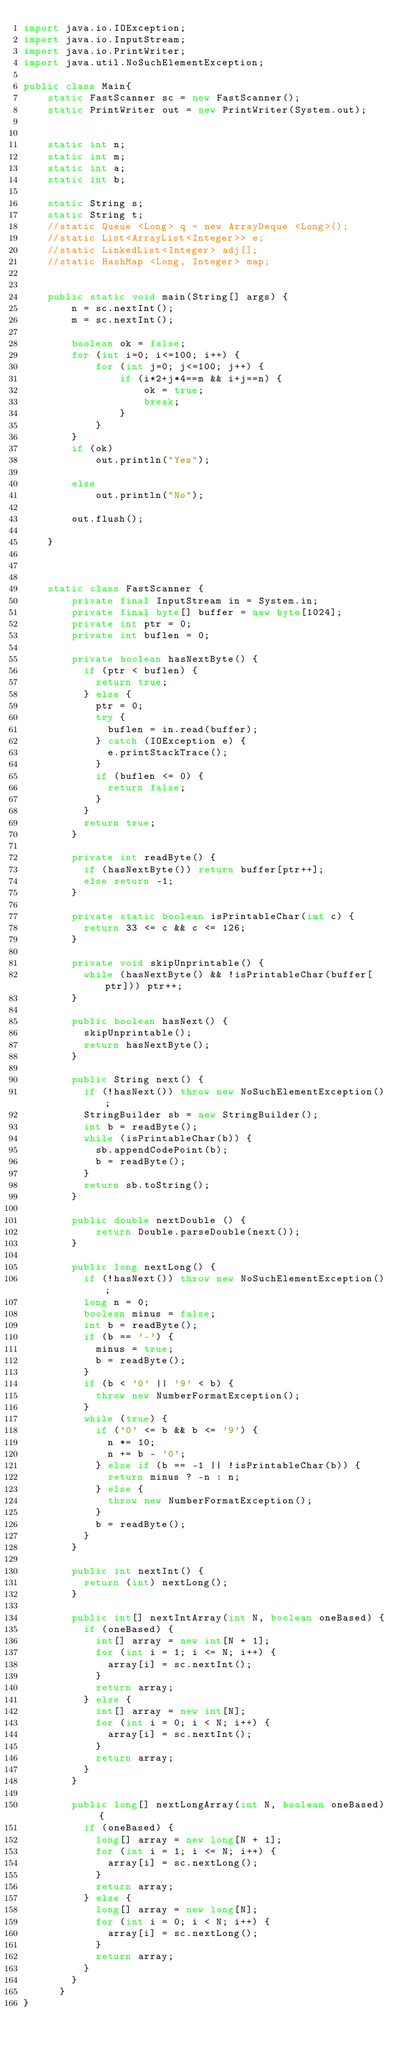Convert code to text. <code><loc_0><loc_0><loc_500><loc_500><_Java_>import java.io.IOException;
import java.io.InputStream;
import java.io.PrintWriter;
import java.util.NoSuchElementException;

public class Main{
	static FastScanner sc = new FastScanner();
	static PrintWriter out = new PrintWriter(System.out);

	
	static int n;
	static int m;
	static int a;
	static int b;
	
	static String s;
	static String t;
	//static Queue <Long> q = new ArrayDeque <Long>();
	//static List<ArrayList<Integer>> e;
	//static LinkedList<Integer> adj[]; 
	//static HashMap <Long, Integer> map;
	
	
	public static void main(String[] args) {
		n = sc.nextInt();
		m = sc.nextInt();
		
		boolean ok = false;
		for (int i=0; i<=100; i++) {
			for (int j=0; j<=100; j++) {
				if (i*2+j*4==m && i+j==n) {
					ok = true;
					break;
				}
			}
		}
		if (ok)
			out.println("Yes");
		
		else 
			out.println("No");
		
		out.flush();
		
	}
	

	
	static class FastScanner {
	    private final InputStream in = System.in;
	    private final byte[] buffer = new byte[1024];
	    private int ptr = 0;
	    private int buflen = 0;

	    private boolean hasNextByte() {
	      if (ptr < buflen) {
	        return true;
	      } else {
	        ptr = 0;
	        try {
	          buflen = in.read(buffer);
	        } catch (IOException e) {
	          e.printStackTrace();
	        }
	        if (buflen <= 0) {
	          return false;
	        }
	      }
	      return true;
	    }

	    private int readByte() {
	      if (hasNextByte()) return buffer[ptr++];
	      else return -1;
	    }

	    private static boolean isPrintableChar(int c) {
	      return 33 <= c && c <= 126;
	    }

	    private void skipUnprintable() {
	      while (hasNextByte() && !isPrintableChar(buffer[ptr])) ptr++;
	    }

	    public boolean hasNext() {
	      skipUnprintable();
	      return hasNextByte();
	    }

	    public String next() {
	      if (!hasNext()) throw new NoSuchElementException();
	      StringBuilder sb = new StringBuilder();
	      int b = readByte();
	      while (isPrintableChar(b)) {
	        sb.appendCodePoint(b);
	        b = readByte();
	      }
	      return sb.toString();
	    }
	    
	    public double nextDouble () {
	    	return Double.parseDouble(next());
	    }

	    public long nextLong() {
	      if (!hasNext()) throw new NoSuchElementException();
	      long n = 0;
	      boolean minus = false;
	      int b = readByte();
	      if (b == '-') {
	        minus = true;
	        b = readByte();
	      }
	      if (b < '0' || '9' < b) {
	        throw new NumberFormatException();
	      }
	      while (true) {
	        if ('0' <= b && b <= '9') {
	          n *= 10;
	          n += b - '0';
	        } else if (b == -1 || !isPrintableChar(b)) {
	          return minus ? -n : n;
	        } else {
	          throw new NumberFormatException();
	        }
	        b = readByte();
	      }
	    }

	    public int nextInt() {
	      return (int) nextLong();
	    }

	    public int[] nextIntArray(int N, boolean oneBased) {
	      if (oneBased) {
	        int[] array = new int[N + 1];
	        for (int i = 1; i <= N; i++) {
	          array[i] = sc.nextInt();
	        }
	        return array;
	      } else {
	        int[] array = new int[N];
	        for (int i = 0; i < N; i++) {
	          array[i] = sc.nextInt();
	        }
	        return array;
	      }
	    }

	    public long[] nextLongArray(int N, boolean oneBased) {
	      if (oneBased) {
	        long[] array = new long[N + 1];
	        for (int i = 1; i <= N; i++) {
	          array[i] = sc.nextLong();
	        }
	        return array;
	      } else {
	        long[] array = new long[N];
	        for (int i = 0; i < N; i++) {
	          array[i] = sc.nextLong();
	        }
	        return array;
	      }
	    }
	  }
}
</code> 